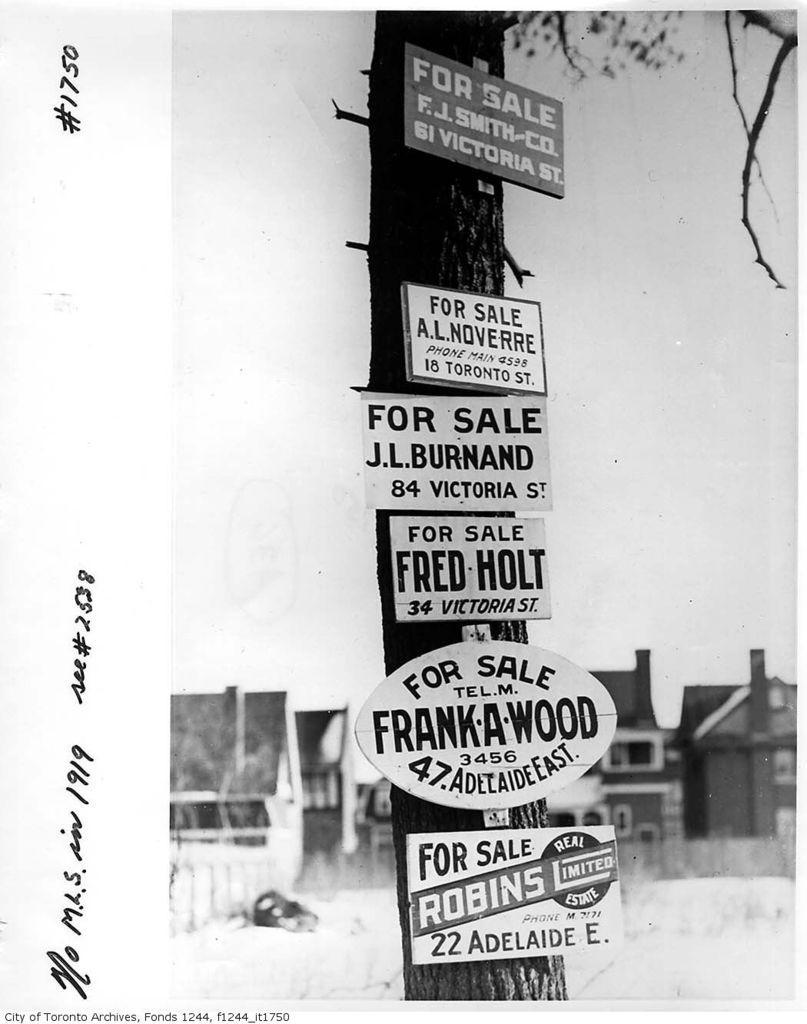Describe this image in one or two sentences. In this picture I can see a poster contains of tree with some boards and also I can see some text on the image. 